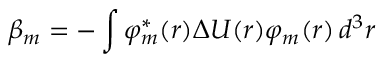<formula> <loc_0><loc_0><loc_500><loc_500>\beta _ { m } = - \int \varphi _ { m } ^ { * } ( { r } ) \Delta U ( { r } ) \varphi _ { m } ( { r } ) \, d ^ { 3 } r</formula> 